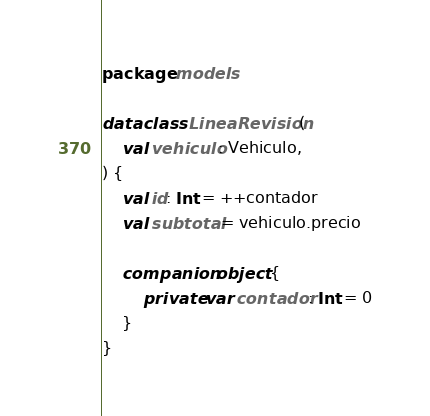Convert code to text. <code><loc_0><loc_0><loc_500><loc_500><_Kotlin_>package models

data class LineaRevision(
    val vehiculo: Vehiculo,
) {
    val id: Int = ++contador
    val subtotal = vehiculo.precio

    companion object {
        private var contador: Int = 0
    }
}
</code> 